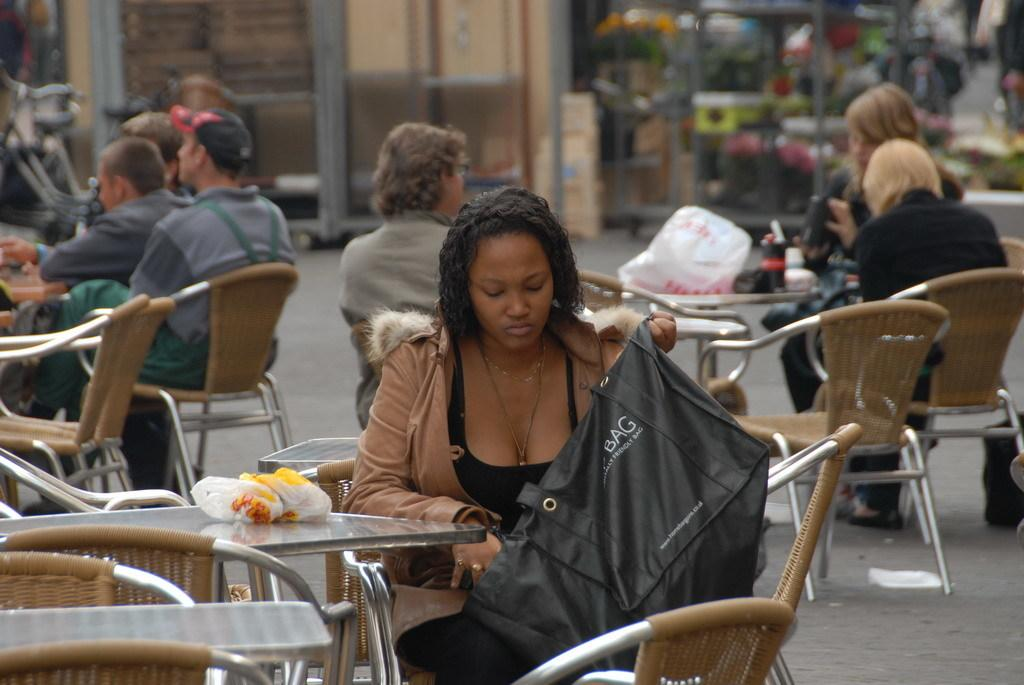What type of furniture is visible in the image? There are tables and chairs in the image. What are the people on the chairs doing? People are seated on the chairs. Where are the chairs located? The chairs are on the road. What can be seen in the background of the image? There are buildings in the background. What is the person at the front holding? The person at the front is holding a black color bag. What type of milk is being served in the class? There is no mention of milk or a class in the image, so it cannot be determined from the image. 